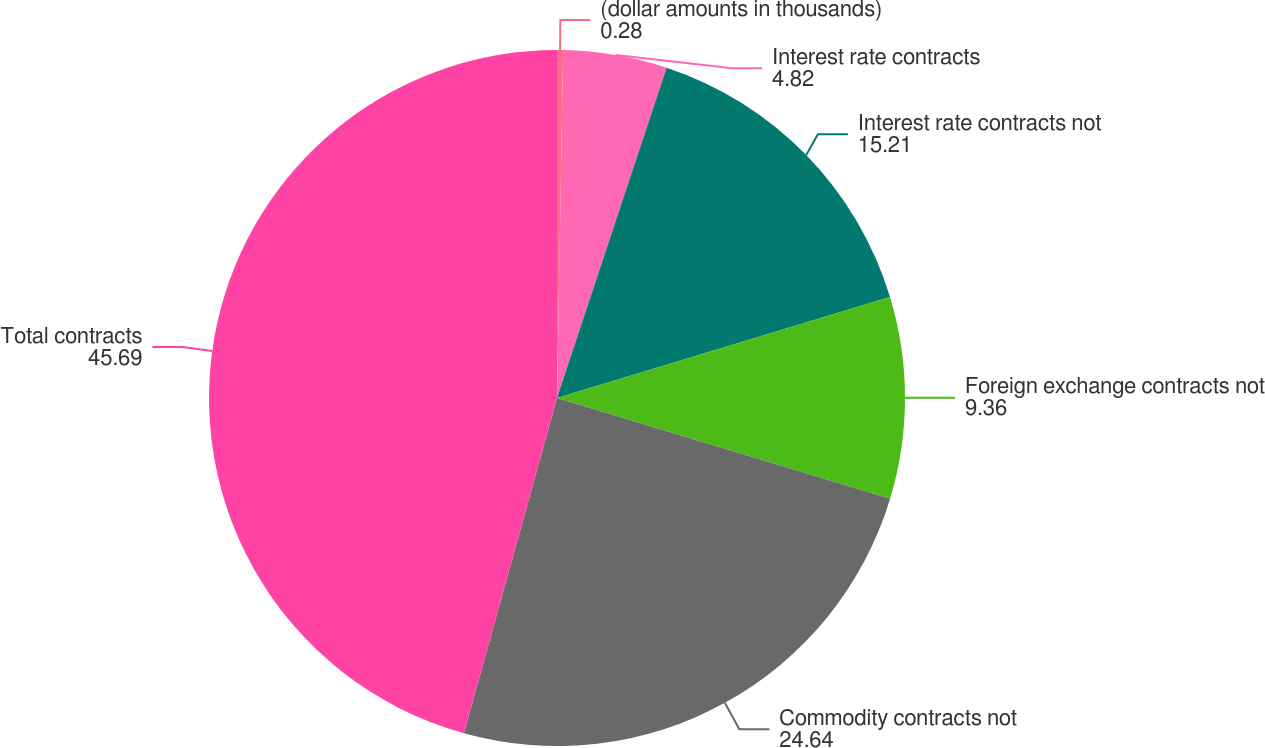<chart> <loc_0><loc_0><loc_500><loc_500><pie_chart><fcel>(dollar amounts in thousands)<fcel>Interest rate contracts<fcel>Interest rate contracts not<fcel>Foreign exchange contracts not<fcel>Commodity contracts not<fcel>Total contracts<nl><fcel>0.28%<fcel>4.82%<fcel>15.21%<fcel>9.36%<fcel>24.64%<fcel>45.69%<nl></chart> 